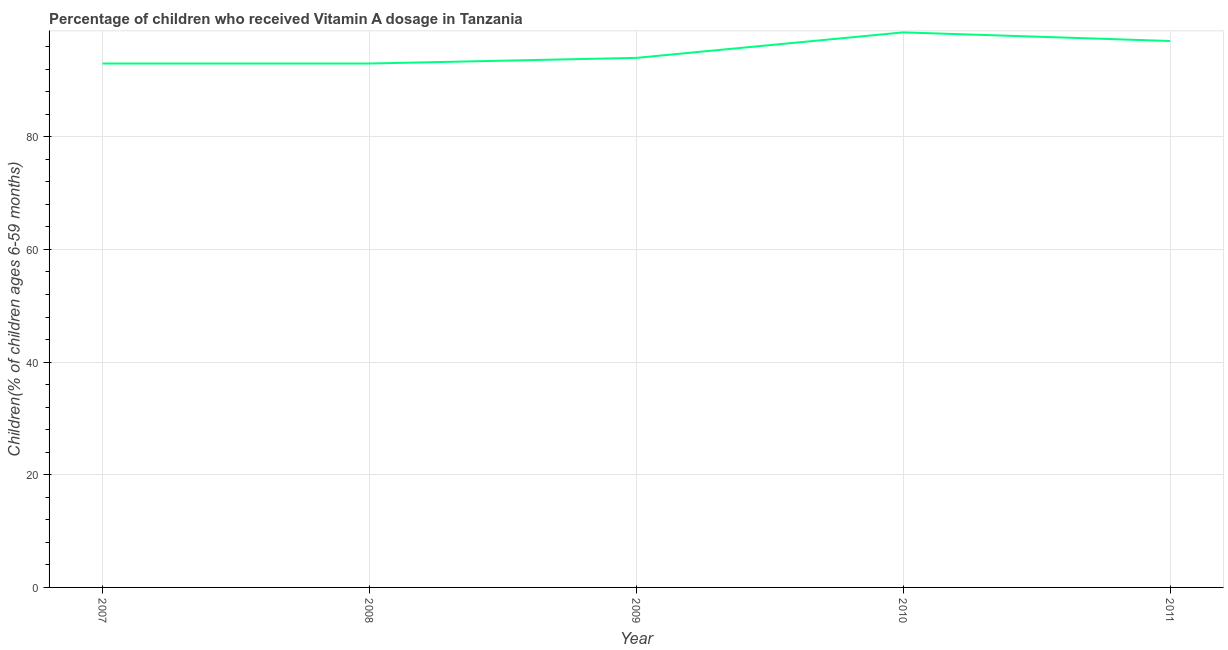What is the vitamin a supplementation coverage rate in 2008?
Ensure brevity in your answer.  93. Across all years, what is the maximum vitamin a supplementation coverage rate?
Make the answer very short. 98.53. Across all years, what is the minimum vitamin a supplementation coverage rate?
Keep it short and to the point. 93. In which year was the vitamin a supplementation coverage rate maximum?
Your answer should be very brief. 2010. What is the sum of the vitamin a supplementation coverage rate?
Make the answer very short. 475.53. What is the average vitamin a supplementation coverage rate per year?
Keep it short and to the point. 95.11. What is the median vitamin a supplementation coverage rate?
Keep it short and to the point. 94. In how many years, is the vitamin a supplementation coverage rate greater than 68 %?
Give a very brief answer. 5. What is the ratio of the vitamin a supplementation coverage rate in 2010 to that in 2011?
Give a very brief answer. 1.02. Is the difference between the vitamin a supplementation coverage rate in 2007 and 2011 greater than the difference between any two years?
Provide a short and direct response. No. What is the difference between the highest and the second highest vitamin a supplementation coverage rate?
Keep it short and to the point. 1.53. Is the sum of the vitamin a supplementation coverage rate in 2008 and 2009 greater than the maximum vitamin a supplementation coverage rate across all years?
Your response must be concise. Yes. What is the difference between the highest and the lowest vitamin a supplementation coverage rate?
Offer a terse response. 5.53. In how many years, is the vitamin a supplementation coverage rate greater than the average vitamin a supplementation coverage rate taken over all years?
Your answer should be compact. 2. How many lines are there?
Provide a short and direct response. 1. What is the difference between two consecutive major ticks on the Y-axis?
Provide a short and direct response. 20. What is the title of the graph?
Provide a succinct answer. Percentage of children who received Vitamin A dosage in Tanzania. What is the label or title of the Y-axis?
Your response must be concise. Children(% of children ages 6-59 months). What is the Children(% of children ages 6-59 months) in 2007?
Give a very brief answer. 93. What is the Children(% of children ages 6-59 months) of 2008?
Provide a short and direct response. 93. What is the Children(% of children ages 6-59 months) of 2009?
Make the answer very short. 94. What is the Children(% of children ages 6-59 months) in 2010?
Offer a very short reply. 98.53. What is the Children(% of children ages 6-59 months) in 2011?
Your response must be concise. 97. What is the difference between the Children(% of children ages 6-59 months) in 2007 and 2008?
Your answer should be very brief. 0. What is the difference between the Children(% of children ages 6-59 months) in 2007 and 2009?
Offer a terse response. -1. What is the difference between the Children(% of children ages 6-59 months) in 2007 and 2010?
Offer a terse response. -5.53. What is the difference between the Children(% of children ages 6-59 months) in 2007 and 2011?
Give a very brief answer. -4. What is the difference between the Children(% of children ages 6-59 months) in 2008 and 2010?
Offer a terse response. -5.53. What is the difference between the Children(% of children ages 6-59 months) in 2008 and 2011?
Your response must be concise. -4. What is the difference between the Children(% of children ages 6-59 months) in 2009 and 2010?
Offer a terse response. -4.53. What is the difference between the Children(% of children ages 6-59 months) in 2010 and 2011?
Ensure brevity in your answer.  1.53. What is the ratio of the Children(% of children ages 6-59 months) in 2007 to that in 2008?
Offer a terse response. 1. What is the ratio of the Children(% of children ages 6-59 months) in 2007 to that in 2009?
Give a very brief answer. 0.99. What is the ratio of the Children(% of children ages 6-59 months) in 2007 to that in 2010?
Make the answer very short. 0.94. What is the ratio of the Children(% of children ages 6-59 months) in 2007 to that in 2011?
Provide a short and direct response. 0.96. What is the ratio of the Children(% of children ages 6-59 months) in 2008 to that in 2009?
Offer a terse response. 0.99. What is the ratio of the Children(% of children ages 6-59 months) in 2008 to that in 2010?
Your response must be concise. 0.94. What is the ratio of the Children(% of children ages 6-59 months) in 2009 to that in 2010?
Make the answer very short. 0.95. 